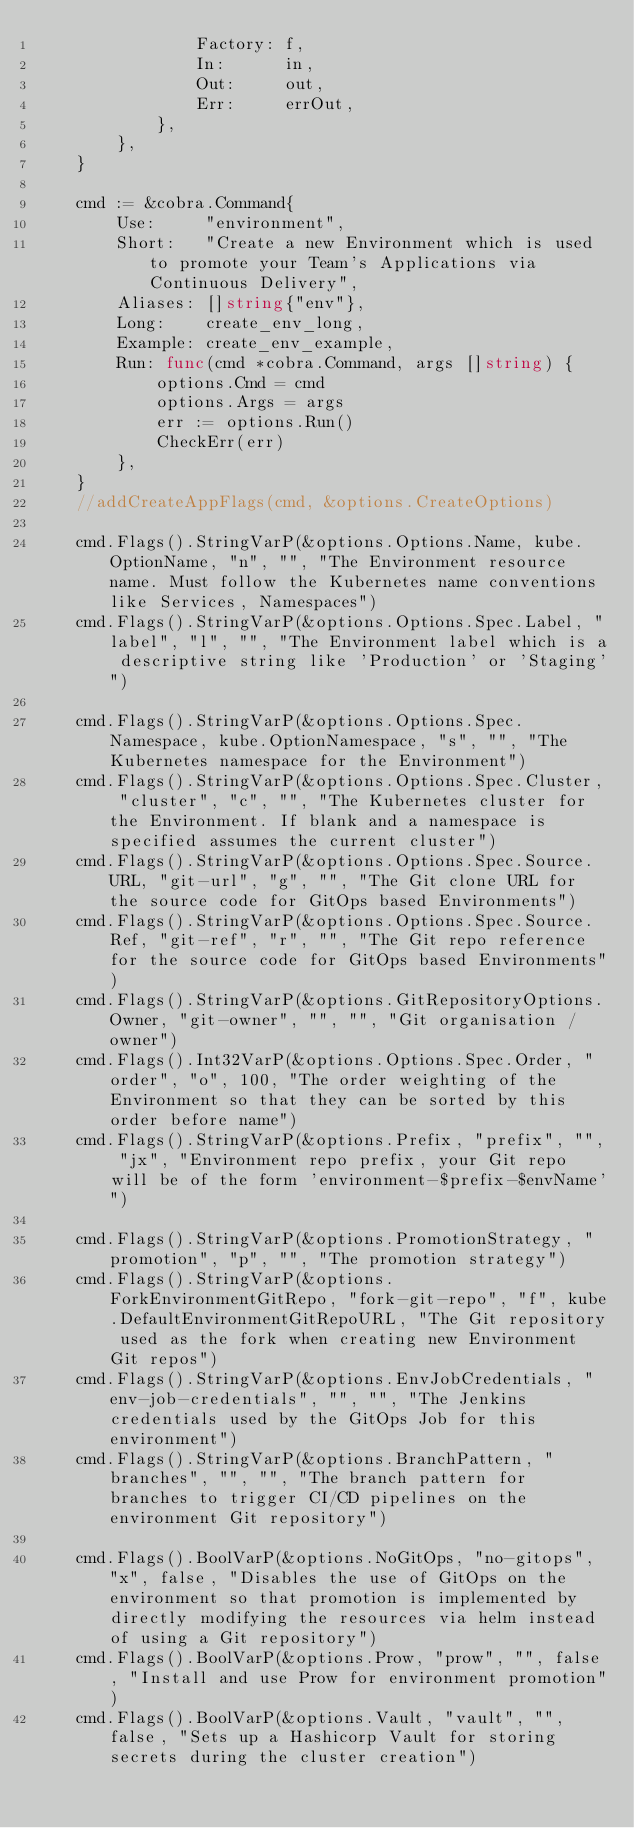Convert code to text. <code><loc_0><loc_0><loc_500><loc_500><_Go_>				Factory: f,
				In:      in,
				Out:     out,
				Err:     errOut,
			},
		},
	}

	cmd := &cobra.Command{
		Use:     "environment",
		Short:   "Create a new Environment which is used to promote your Team's Applications via Continuous Delivery",
		Aliases: []string{"env"},
		Long:    create_env_long,
		Example: create_env_example,
		Run: func(cmd *cobra.Command, args []string) {
			options.Cmd = cmd
			options.Args = args
			err := options.Run()
			CheckErr(err)
		},
	}
	//addCreateAppFlags(cmd, &options.CreateOptions)

	cmd.Flags().StringVarP(&options.Options.Name, kube.OptionName, "n", "", "The Environment resource name. Must follow the Kubernetes name conventions like Services, Namespaces")
	cmd.Flags().StringVarP(&options.Options.Spec.Label, "label", "l", "", "The Environment label which is a descriptive string like 'Production' or 'Staging'")

	cmd.Flags().StringVarP(&options.Options.Spec.Namespace, kube.OptionNamespace, "s", "", "The Kubernetes namespace for the Environment")
	cmd.Flags().StringVarP(&options.Options.Spec.Cluster, "cluster", "c", "", "The Kubernetes cluster for the Environment. If blank and a namespace is specified assumes the current cluster")
	cmd.Flags().StringVarP(&options.Options.Spec.Source.URL, "git-url", "g", "", "The Git clone URL for the source code for GitOps based Environments")
	cmd.Flags().StringVarP(&options.Options.Spec.Source.Ref, "git-ref", "r", "", "The Git repo reference for the source code for GitOps based Environments")
	cmd.Flags().StringVarP(&options.GitRepositoryOptions.Owner, "git-owner", "", "", "Git organisation / owner")
	cmd.Flags().Int32VarP(&options.Options.Spec.Order, "order", "o", 100, "The order weighting of the Environment so that they can be sorted by this order before name")
	cmd.Flags().StringVarP(&options.Prefix, "prefix", "", "jx", "Environment repo prefix, your Git repo will be of the form 'environment-$prefix-$envName'")

	cmd.Flags().StringVarP(&options.PromotionStrategy, "promotion", "p", "", "The promotion strategy")
	cmd.Flags().StringVarP(&options.ForkEnvironmentGitRepo, "fork-git-repo", "f", kube.DefaultEnvironmentGitRepoURL, "The Git repository used as the fork when creating new Environment Git repos")
	cmd.Flags().StringVarP(&options.EnvJobCredentials, "env-job-credentials", "", "", "The Jenkins credentials used by the GitOps Job for this environment")
	cmd.Flags().StringVarP(&options.BranchPattern, "branches", "", "", "The branch pattern for branches to trigger CI/CD pipelines on the environment Git repository")

	cmd.Flags().BoolVarP(&options.NoGitOps, "no-gitops", "x", false, "Disables the use of GitOps on the environment so that promotion is implemented by directly modifying the resources via helm instead of using a Git repository")
	cmd.Flags().BoolVarP(&options.Prow, "prow", "", false, "Install and use Prow for environment promotion")
	cmd.Flags().BoolVarP(&options.Vault, "vault", "", false, "Sets up a Hashicorp Vault for storing secrets during the cluster creation")
</code> 